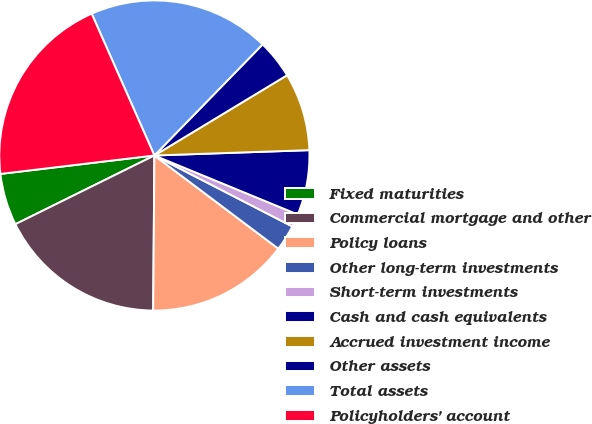<chart> <loc_0><loc_0><loc_500><loc_500><pie_chart><fcel>Fixed maturities<fcel>Commercial mortgage and other<fcel>Policy loans<fcel>Other long-term investments<fcel>Short-term investments<fcel>Cash and cash equivalents<fcel>Accrued investment income<fcel>Other assets<fcel>Total assets<fcel>Policyholders' account<nl><fcel>5.41%<fcel>17.57%<fcel>14.86%<fcel>2.7%<fcel>1.35%<fcel>6.76%<fcel>8.11%<fcel>4.05%<fcel>18.92%<fcel>20.27%<nl></chart> 